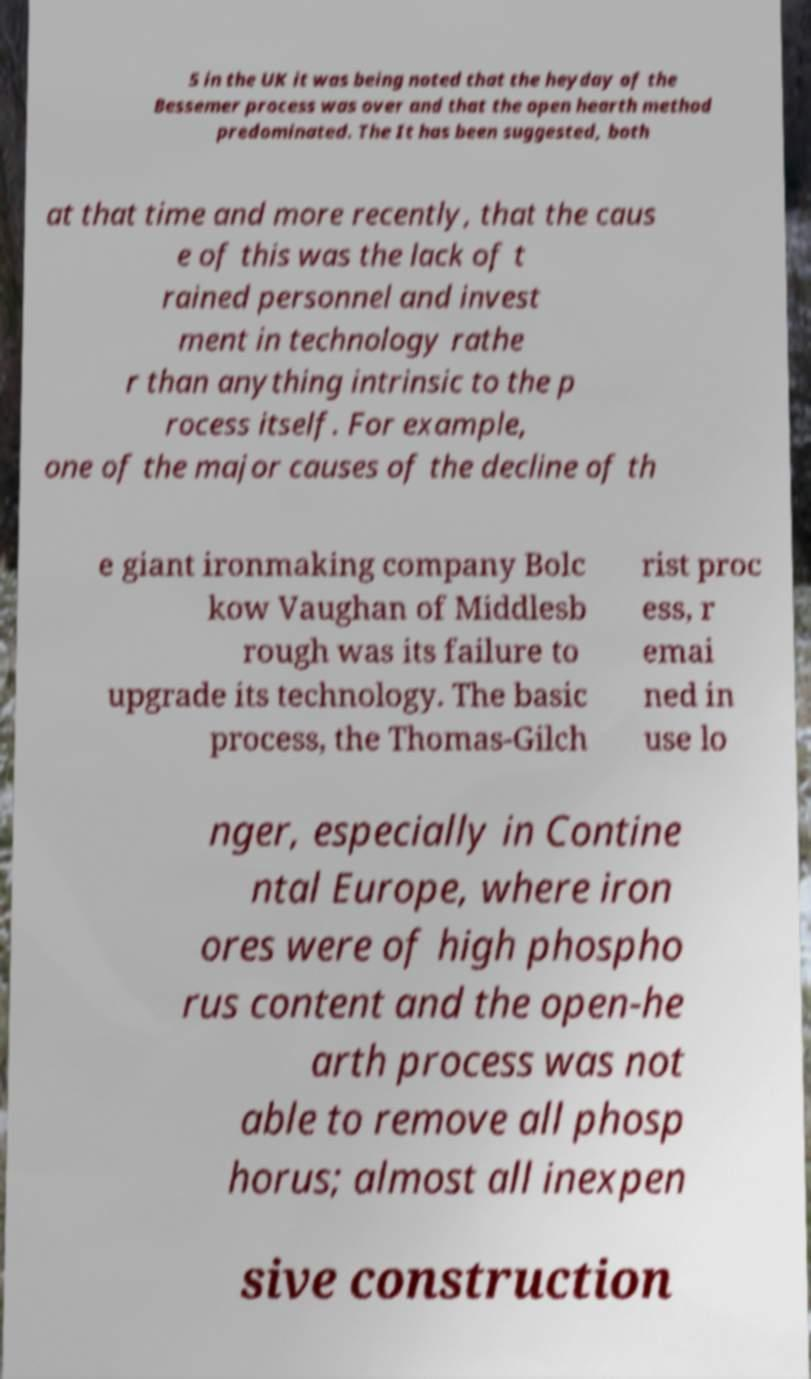There's text embedded in this image that I need extracted. Can you transcribe it verbatim? 5 in the UK it was being noted that the heyday of the Bessemer process was over and that the open hearth method predominated. The It has been suggested, both at that time and more recently, that the caus e of this was the lack of t rained personnel and invest ment in technology rathe r than anything intrinsic to the p rocess itself. For example, one of the major causes of the decline of th e giant ironmaking company Bolc kow Vaughan of Middlesb rough was its failure to upgrade its technology. The basic process, the Thomas-Gilch rist proc ess, r emai ned in use lo nger, especially in Contine ntal Europe, where iron ores were of high phospho rus content and the open-he arth process was not able to remove all phosp horus; almost all inexpen sive construction 